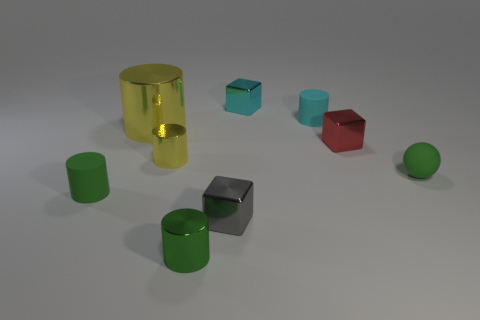Can you describe the differences between the objects on the left side compared to those on the right? On the left side, there are two green cylindrical objects and a reflective yellow cylinder, all featuring a matte and glossy finish, respectively. On the right, there are a small red cube, a small teal cube, and a green sphere. The objects on the left seem to have a more uniform shape, while those on the right exhibit more variety in both shape and color. 